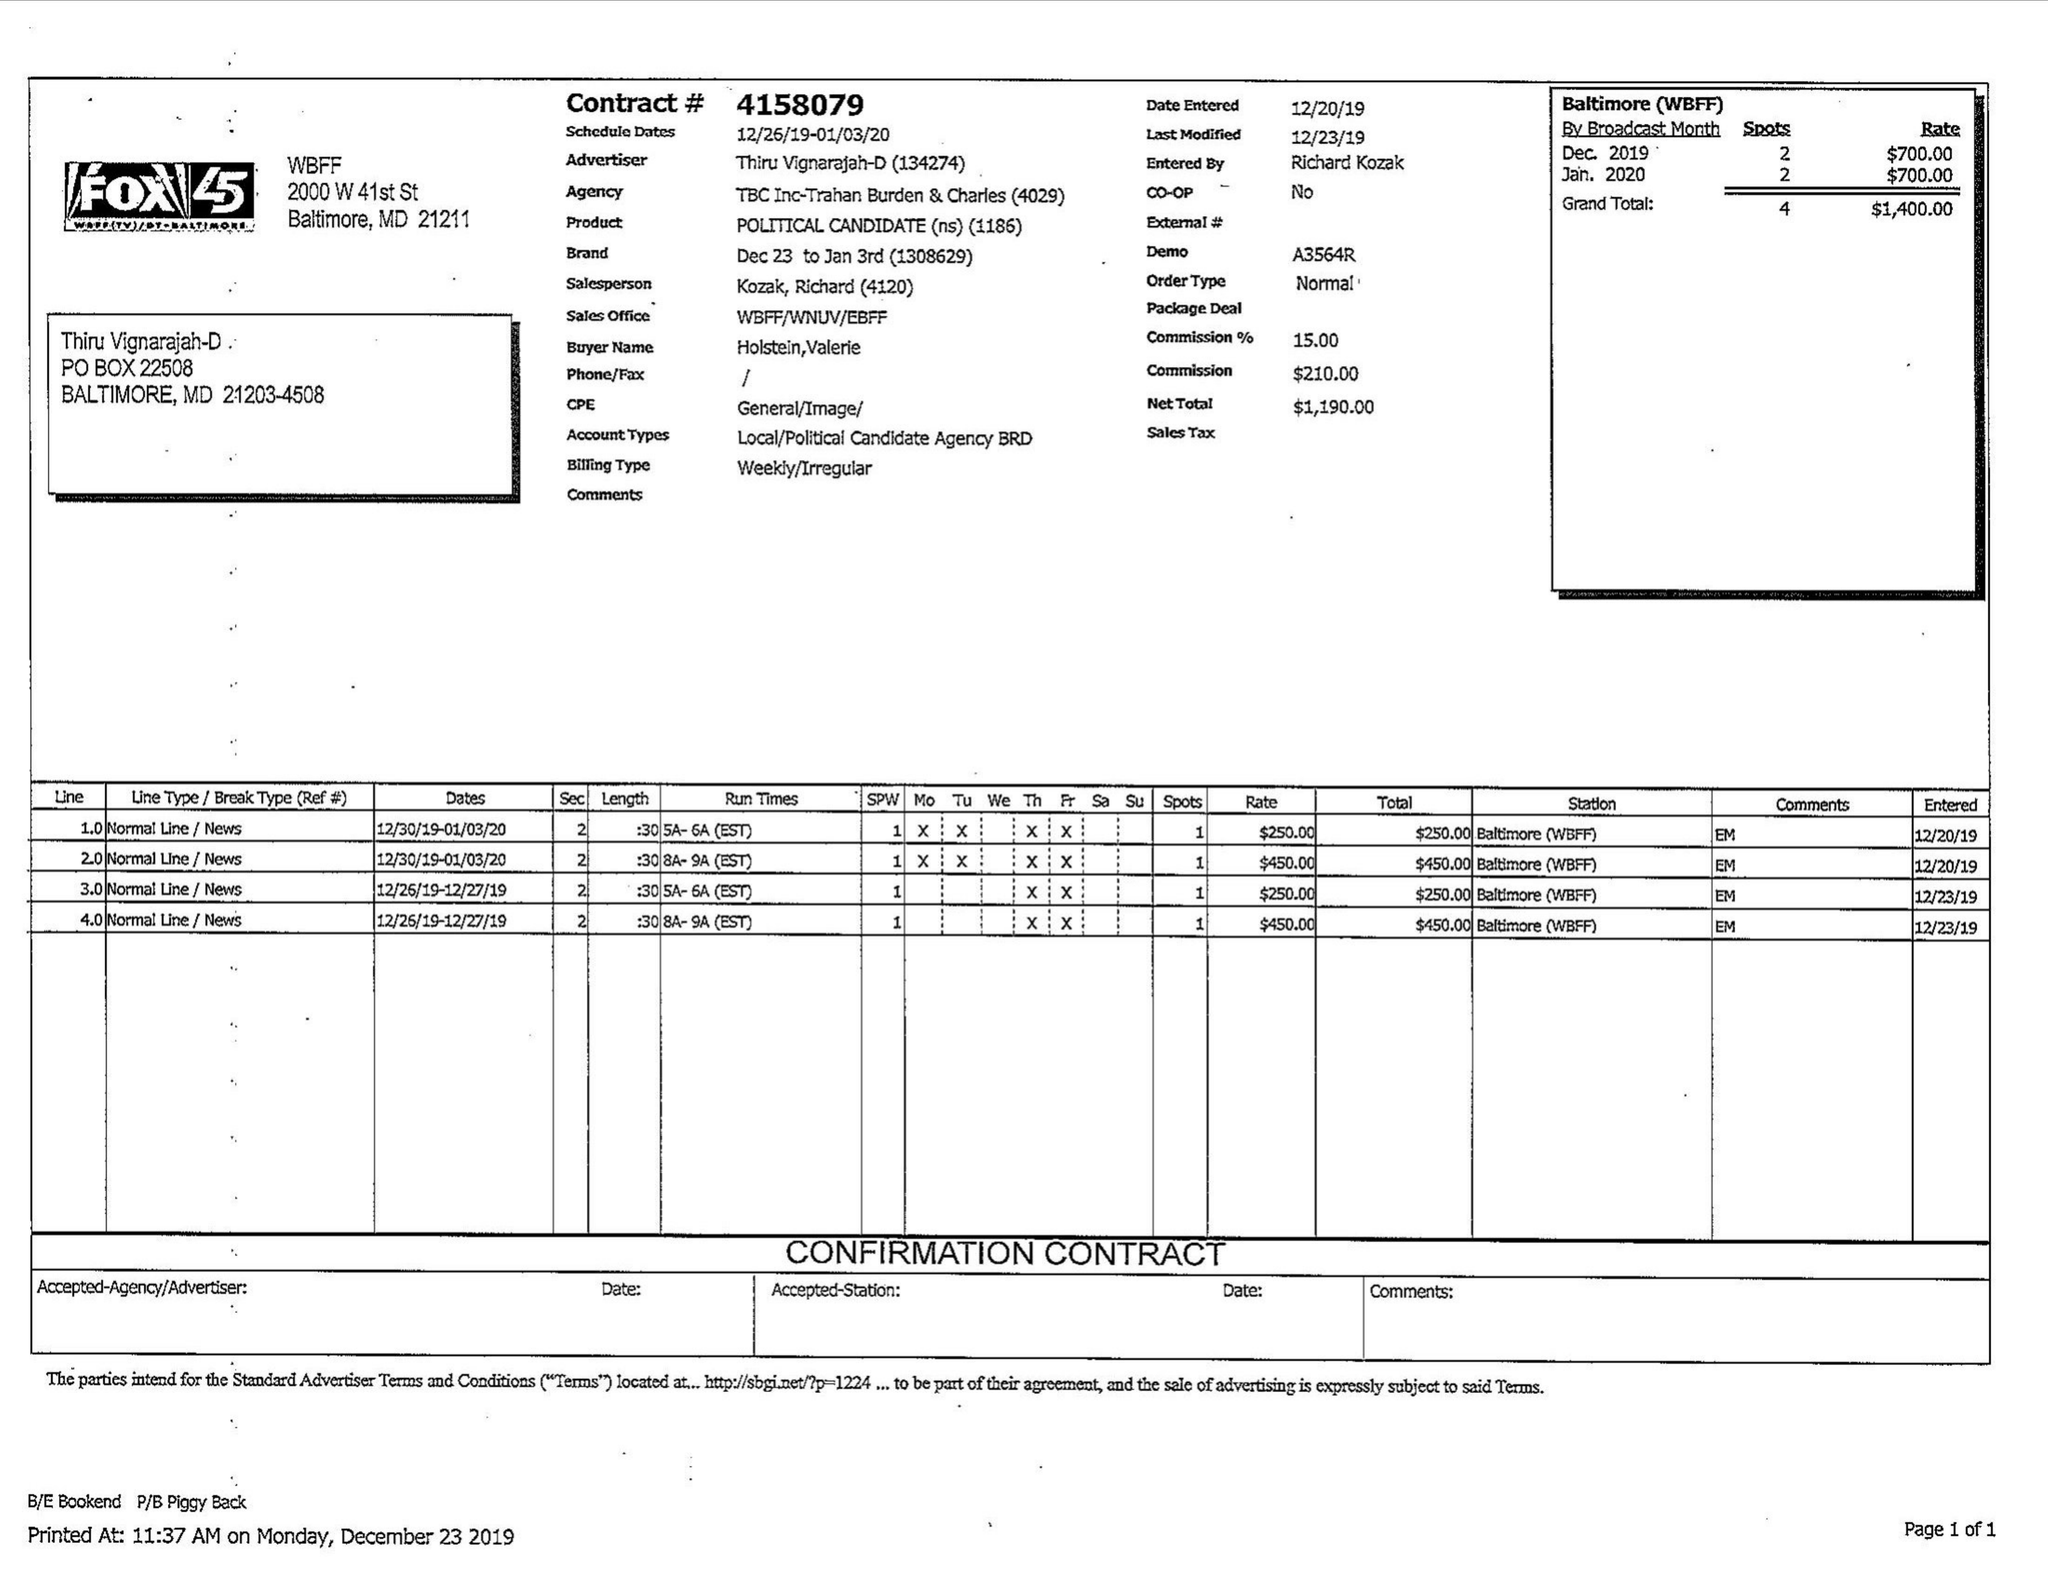What is the value for the flight_to?
Answer the question using a single word or phrase. 01/03/20 